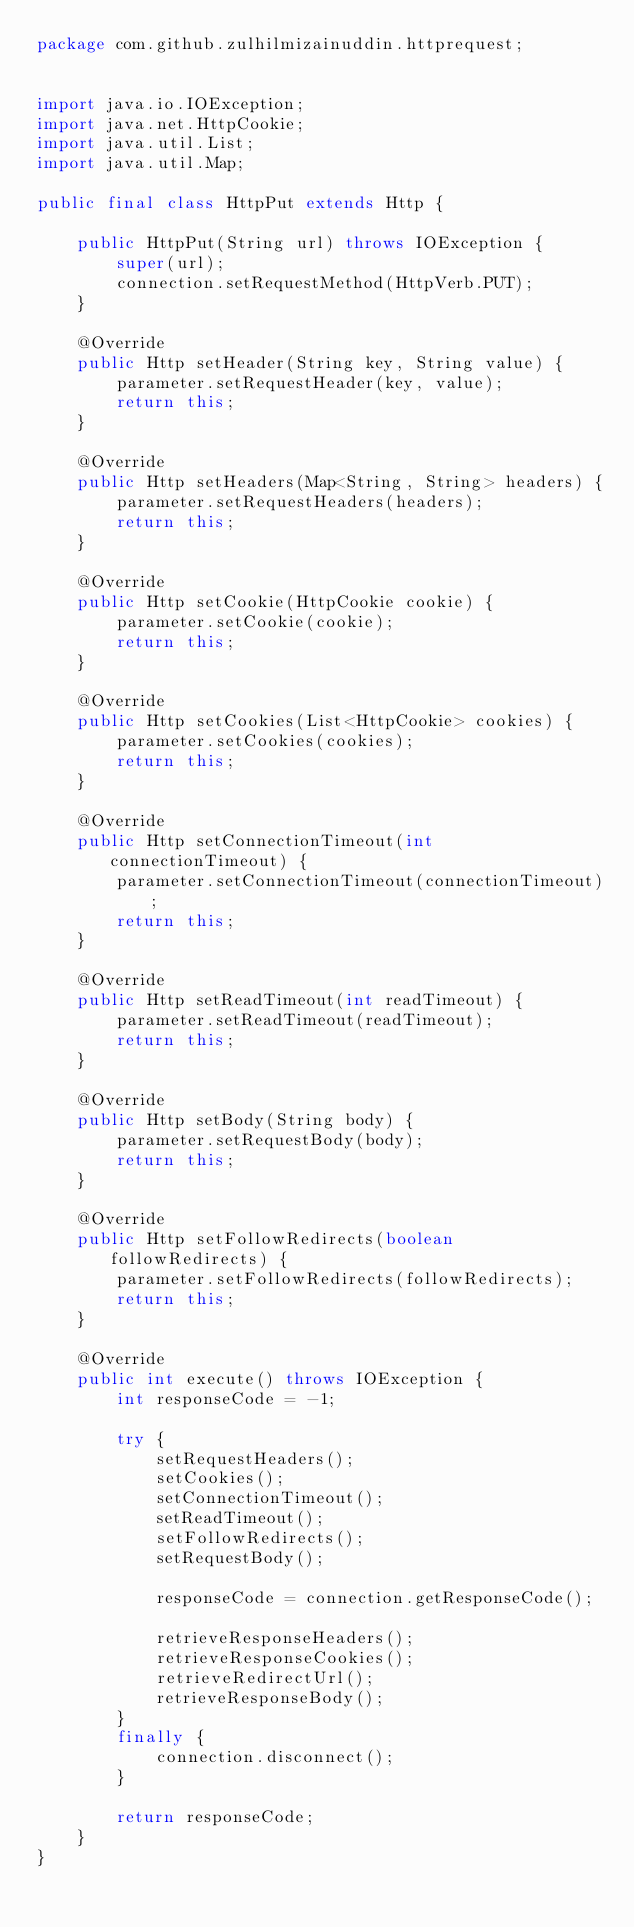<code> <loc_0><loc_0><loc_500><loc_500><_Java_>package com.github.zulhilmizainuddin.httprequest;


import java.io.IOException;
import java.net.HttpCookie;
import java.util.List;
import java.util.Map;

public final class HttpPut extends Http {

    public HttpPut(String url) throws IOException {
        super(url);
        connection.setRequestMethod(HttpVerb.PUT);
    }

    @Override
    public Http setHeader(String key, String value) {
        parameter.setRequestHeader(key, value);
        return this;
    }

    @Override
    public Http setHeaders(Map<String, String> headers) {
        parameter.setRequestHeaders(headers);
        return this;
    }

    @Override
    public Http setCookie(HttpCookie cookie) {
        parameter.setCookie(cookie);
        return this;
    }

    @Override
    public Http setCookies(List<HttpCookie> cookies) {
        parameter.setCookies(cookies);
        return this;
    }

    @Override
    public Http setConnectionTimeout(int connectionTimeout) {
        parameter.setConnectionTimeout(connectionTimeout);
        return this;
    }

    @Override
    public Http setReadTimeout(int readTimeout) {
        parameter.setReadTimeout(readTimeout);
        return this;
    }

    @Override
    public Http setBody(String body) {
        parameter.setRequestBody(body);
        return this;
    }

    @Override
    public Http setFollowRedirects(boolean followRedirects) {
        parameter.setFollowRedirects(followRedirects);
        return this;
    }

    @Override
    public int execute() throws IOException {
        int responseCode = -1;

        try {
            setRequestHeaders();
            setCookies();
            setConnectionTimeout();
            setReadTimeout();
            setFollowRedirects();
            setRequestBody();

            responseCode = connection.getResponseCode();

            retrieveResponseHeaders();
            retrieveResponseCookies();
            retrieveRedirectUrl();
            retrieveResponseBody();
        }
        finally {
            connection.disconnect();
        }

        return responseCode;
    }
}
</code> 